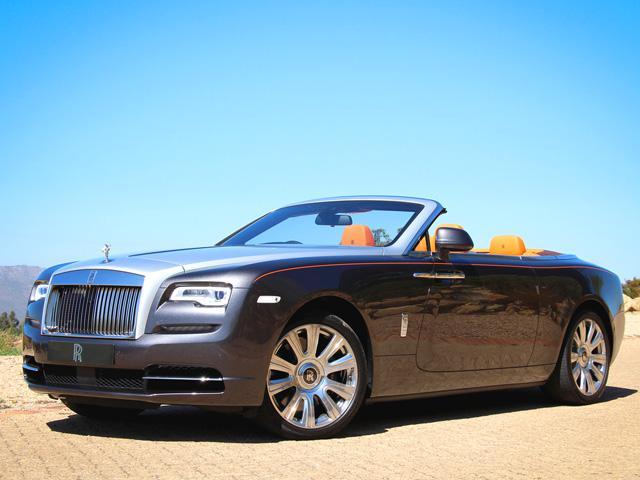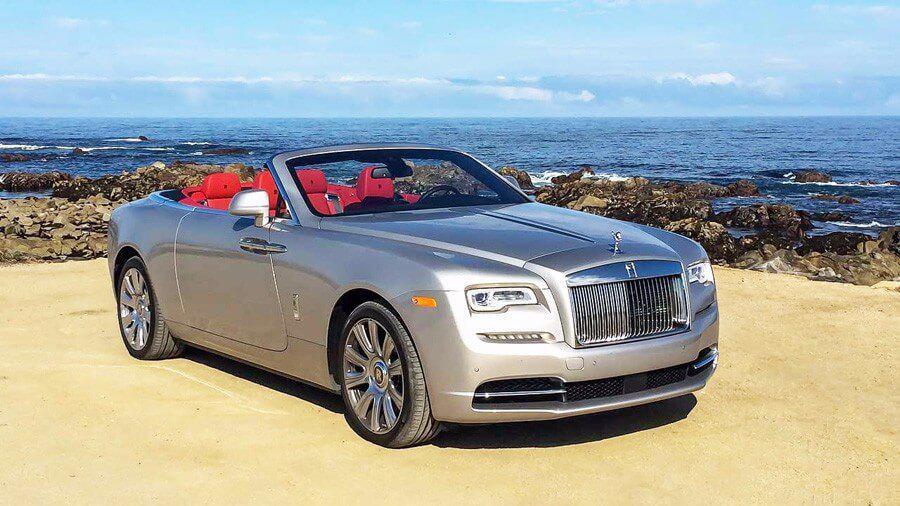The first image is the image on the left, the second image is the image on the right. For the images shown, is this caption "In each image there is a blue convertible that is facing the left." true? Answer yes or no. No. 